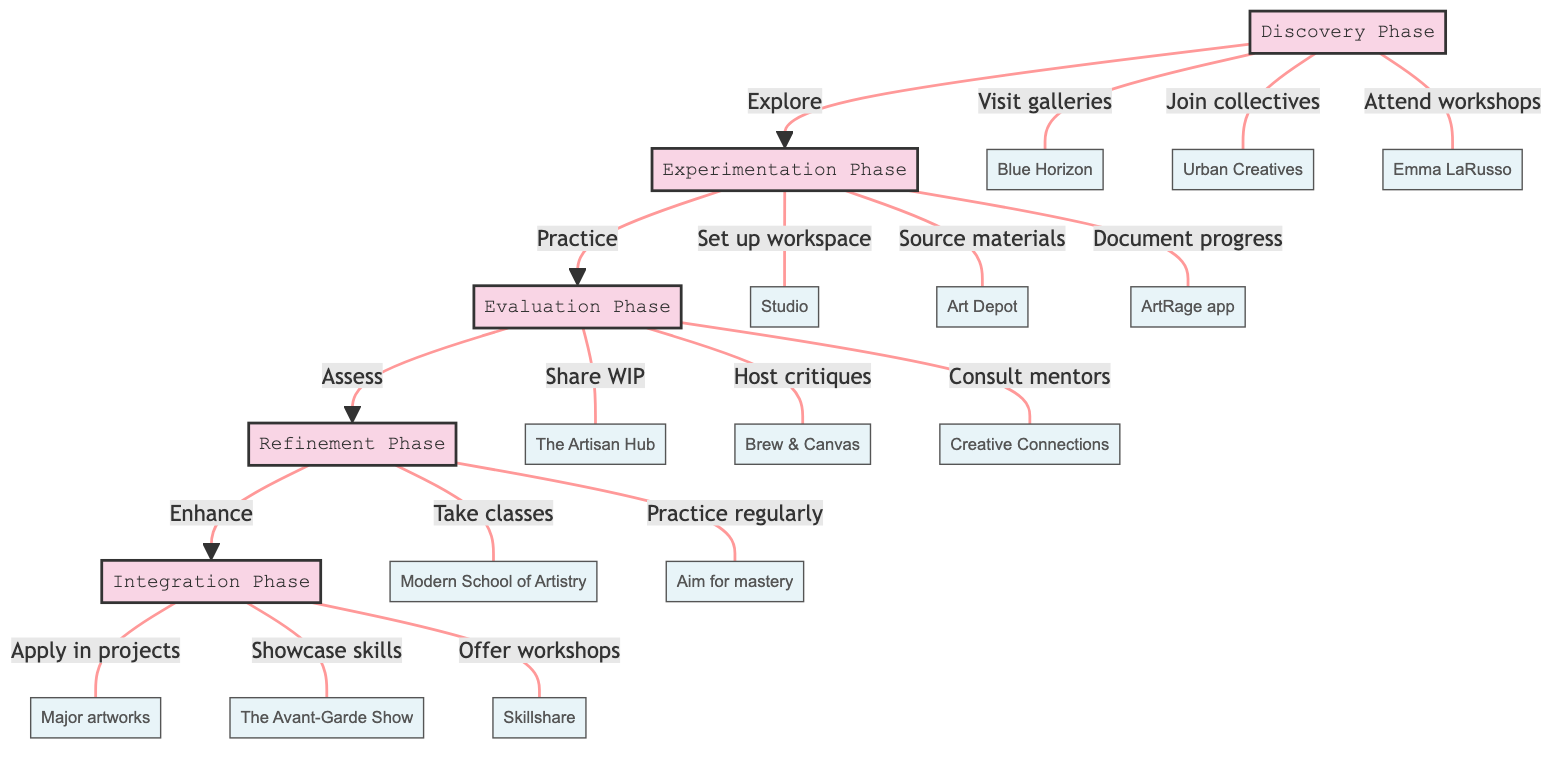What's the title of the diagram? The title node clearly states "Workflow for Integrating New Artistic Techniques - From Experimentation to Mastery." It is directly available at the top of the diagram.
Answer: Workflow for Integrating New Artistic Techniques - From Experimentation to Mastery How many phases are in the workflow? By counting the steps outlined in the diagram, we can see there are five distinct phases outlined: Discovery, Experimentation, Evaluation, Refinement, and Integration.
Answer: 5 What follows the Experimentation Phase? In the diagram, an arrow from the Experimentation Phase points directly to the Evaluation Phase, indicating that Evaluation comes next in the workflow.
Answer: Evaluation Phase Which location is associated with the Discovery Phase? There are multiple locations under the Discovery Phase, but "Blue Horizon" is one of them, listed as a place to visit.
Answer: Blue Horizon What action is associated with the Integration Phase? The Integration Phase includes several actions, one of which is "Apply refined techniques in your major projects." This action outlines an essential step of integrating techniques into artwork.
Answer: Apply refined techniques in your major projects Which phase involves documenting progress? The Experimentation Phase includes the component of "Document your process and progress using art journals and apps like ArtRage," which specifies the action of documentation.
Answer: Experimentation Phase What is the final phase in the workflow? The flow of the diagram leads to the Integration Phase, which is the last phase, indicating it's the culmination of the previous steps.
Answer: Integration Phase What type of critique sessions are hosted during the Evaluation Phase? The Evaluation Phase mentions hosting "informal critique sessions," emphasizing the casual nature of this feedback process.
Answer: Informal critique sessions What is the purpose of the Refinement Phase? The primary goal of the Refinement Phase is to "refine and enhance chosen techniques," focusing on improving and perfecting artistic skills.
Answer: Refine and enhance chosen techniques 